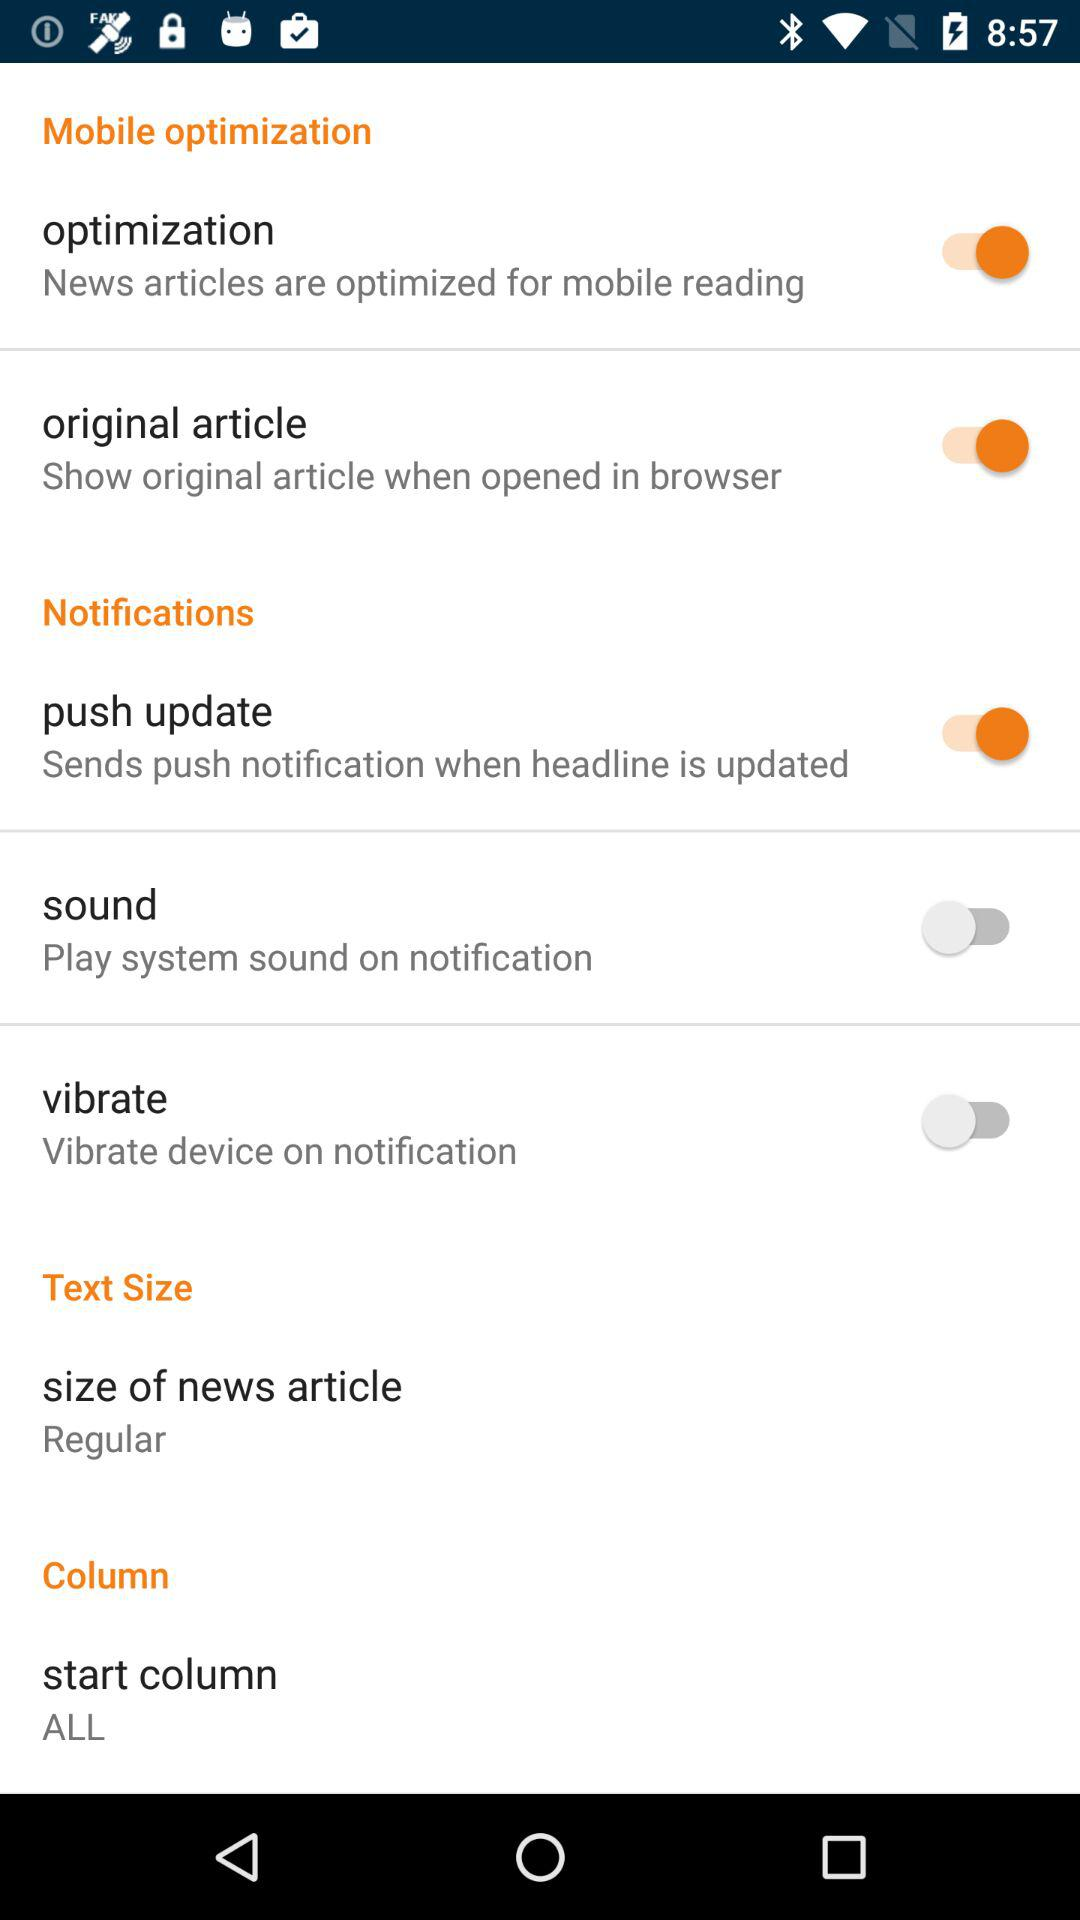What is the status of the "sound"? The status is "off". 